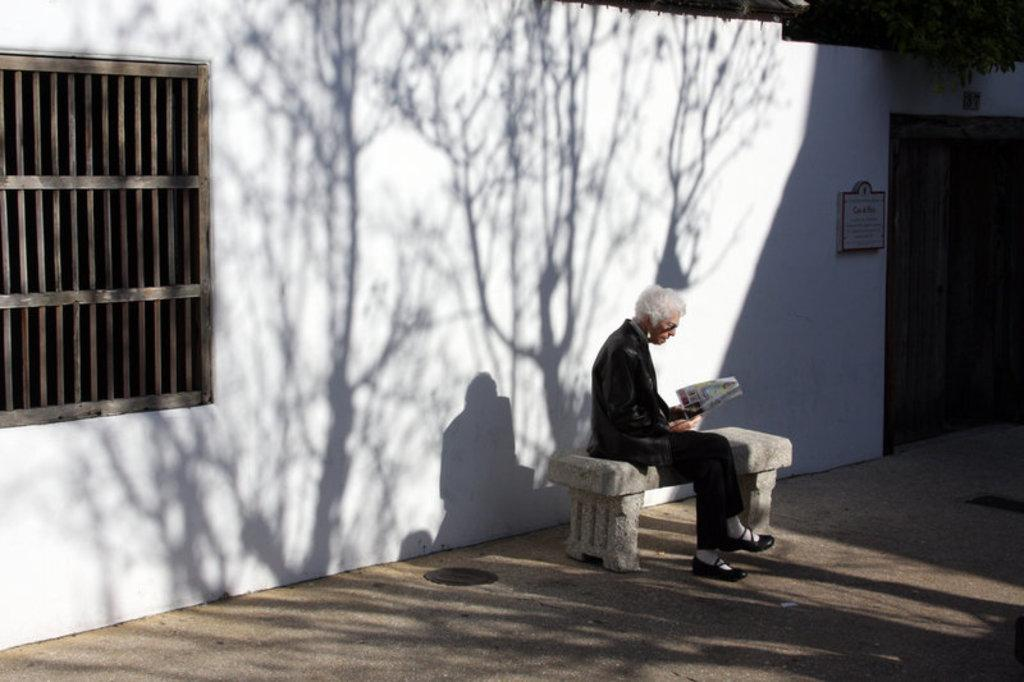Who is in the image? There is a person in the image. What is the person doing in the image? The person is sitting on a bench. What is the person holding in the image? The person is holding a book. What can be seen in the background of the image? There is a building, a door, and a window visible in the background of the image. What type of statement can be seen on the stove in the image? There is no stove present in the image, and therefore no statement can be seen on it. 